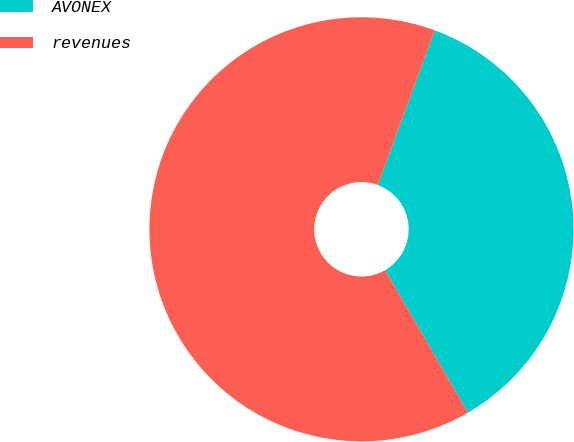Convert chart to OTSL. <chart><loc_0><loc_0><loc_500><loc_500><pie_chart><fcel>AVONEX<fcel>revenues<nl><fcel>36.0%<fcel>64.0%<nl></chart> 